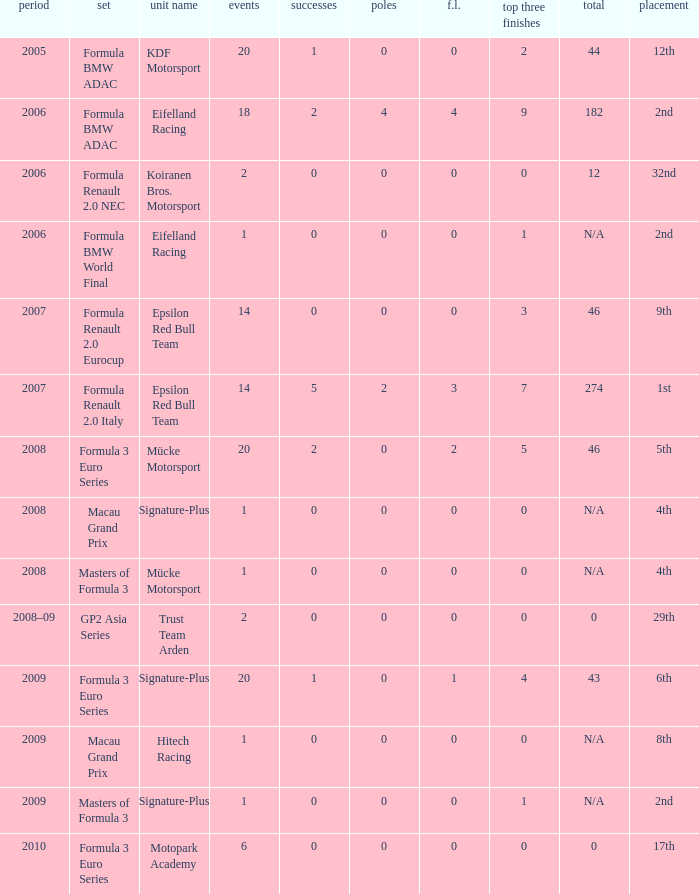What is the race in the 8th position? 1.0. Write the full table. {'header': ['period', 'set', 'unit name', 'events', 'successes', 'poles', 'f.l.', 'top three finishes', 'total', 'placement'], 'rows': [['2005', 'Formula BMW ADAC', 'KDF Motorsport', '20', '1', '0', '0', '2', '44', '12th'], ['2006', 'Formula BMW ADAC', 'Eifelland Racing', '18', '2', '4', '4', '9', '182', '2nd'], ['2006', 'Formula Renault 2.0 NEC', 'Koiranen Bros. Motorsport', '2', '0', '0', '0', '0', '12', '32nd'], ['2006', 'Formula BMW World Final', 'Eifelland Racing', '1', '0', '0', '0', '1', 'N/A', '2nd'], ['2007', 'Formula Renault 2.0 Eurocup', 'Epsilon Red Bull Team', '14', '0', '0', '0', '3', '46', '9th'], ['2007', 'Formula Renault 2.0 Italy', 'Epsilon Red Bull Team', '14', '5', '2', '3', '7', '274', '1st'], ['2008', 'Formula 3 Euro Series', 'Mücke Motorsport', '20', '2', '0', '2', '5', '46', '5th'], ['2008', 'Macau Grand Prix', 'Signature-Plus', '1', '0', '0', '0', '0', 'N/A', '4th'], ['2008', 'Masters of Formula 3', 'Mücke Motorsport', '1', '0', '0', '0', '0', 'N/A', '4th'], ['2008–09', 'GP2 Asia Series', 'Trust Team Arden', '2', '0', '0', '0', '0', '0', '29th'], ['2009', 'Formula 3 Euro Series', 'Signature-Plus', '20', '1', '0', '1', '4', '43', '6th'], ['2009', 'Macau Grand Prix', 'Hitech Racing', '1', '0', '0', '0', '0', 'N/A', '8th'], ['2009', 'Masters of Formula 3', 'Signature-Plus', '1', '0', '0', '0', '1', 'N/A', '2nd'], ['2010', 'Formula 3 Euro Series', 'Motopark Academy', '6', '0', '0', '0', '0', '0', '17th']]} 